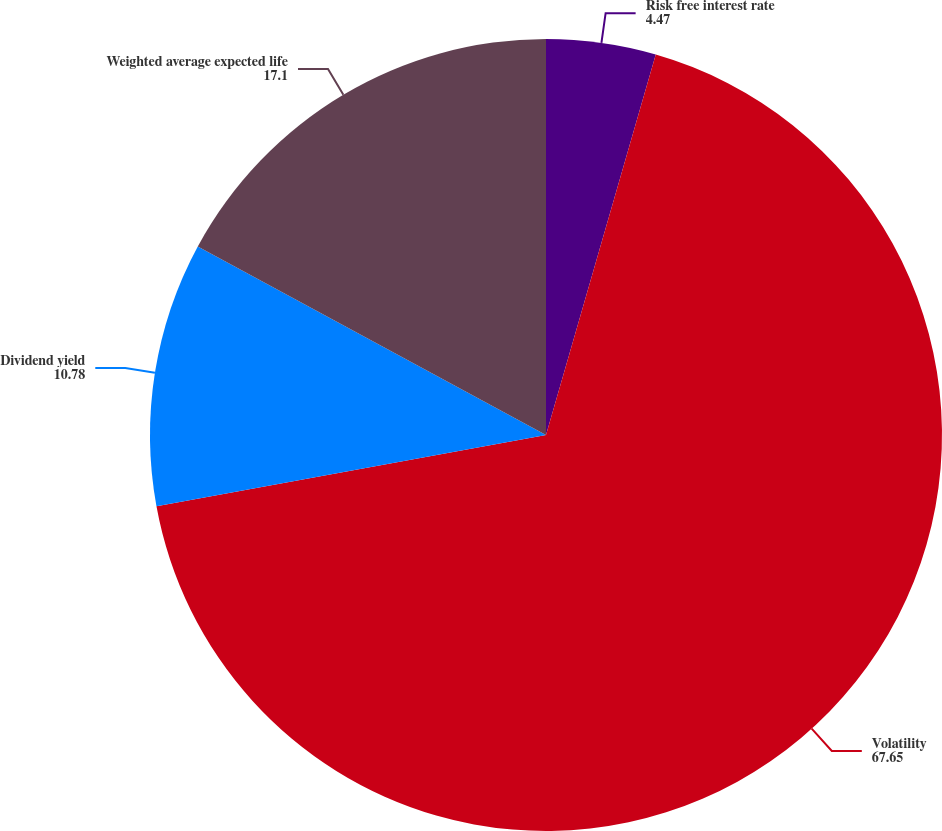Convert chart. <chart><loc_0><loc_0><loc_500><loc_500><pie_chart><fcel>Risk free interest rate<fcel>Volatility<fcel>Dividend yield<fcel>Weighted average expected life<nl><fcel>4.47%<fcel>67.65%<fcel>10.78%<fcel>17.1%<nl></chart> 